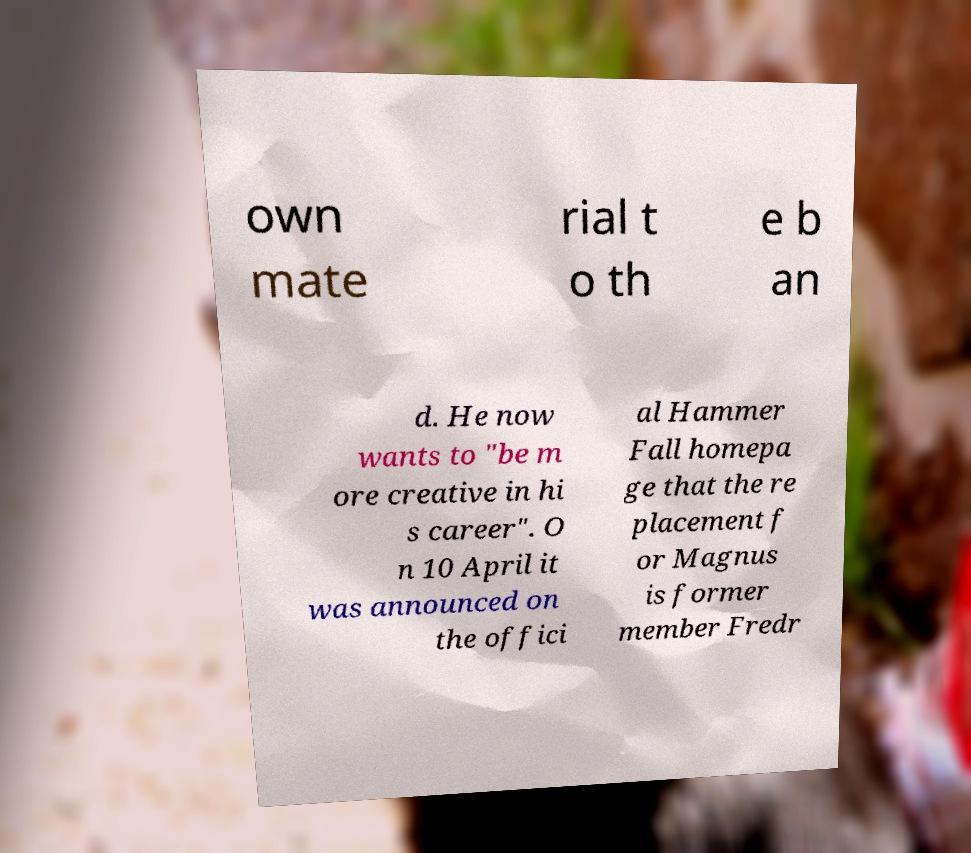Could you assist in decoding the text presented in this image and type it out clearly? own mate rial t o th e b an d. He now wants to "be m ore creative in hi s career". O n 10 April it was announced on the offici al Hammer Fall homepa ge that the re placement f or Magnus is former member Fredr 